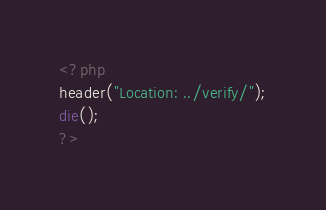<code> <loc_0><loc_0><loc_500><loc_500><_PHP_><?php
header("Location: ../verify/");
die();
?></code> 